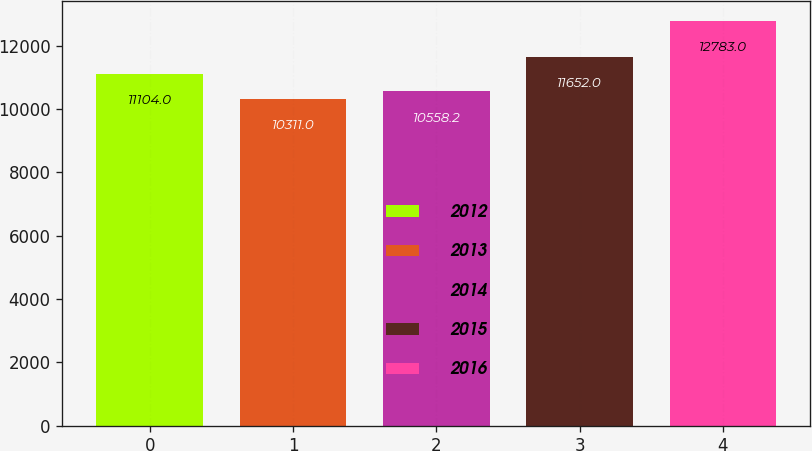Convert chart. <chart><loc_0><loc_0><loc_500><loc_500><bar_chart><fcel>2012<fcel>2013<fcel>2014<fcel>2015<fcel>2016<nl><fcel>11104<fcel>10311<fcel>10558.2<fcel>11652<fcel>12783<nl></chart> 